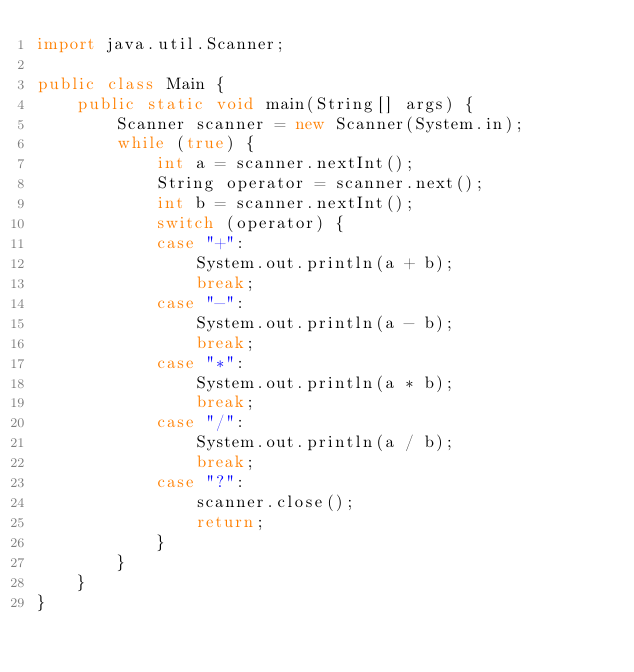Convert code to text. <code><loc_0><loc_0><loc_500><loc_500><_Java_>import java.util.Scanner;

public class Main {
    public static void main(String[] args) {
        Scanner scanner = new Scanner(System.in);
        while (true) {
            int a = scanner.nextInt();
            String operator = scanner.next();
            int b = scanner.nextInt();
            switch (operator) {
            case "+":
                System.out.println(a + b);
                break;
            case "-":
                System.out.println(a - b);
                break;
            case "*":
                System.out.println(a * b);
                break;
            case "/":
                System.out.println(a / b);
                break;
            case "?":
                scanner.close();
                return;
            }
        }
    }
}

</code> 